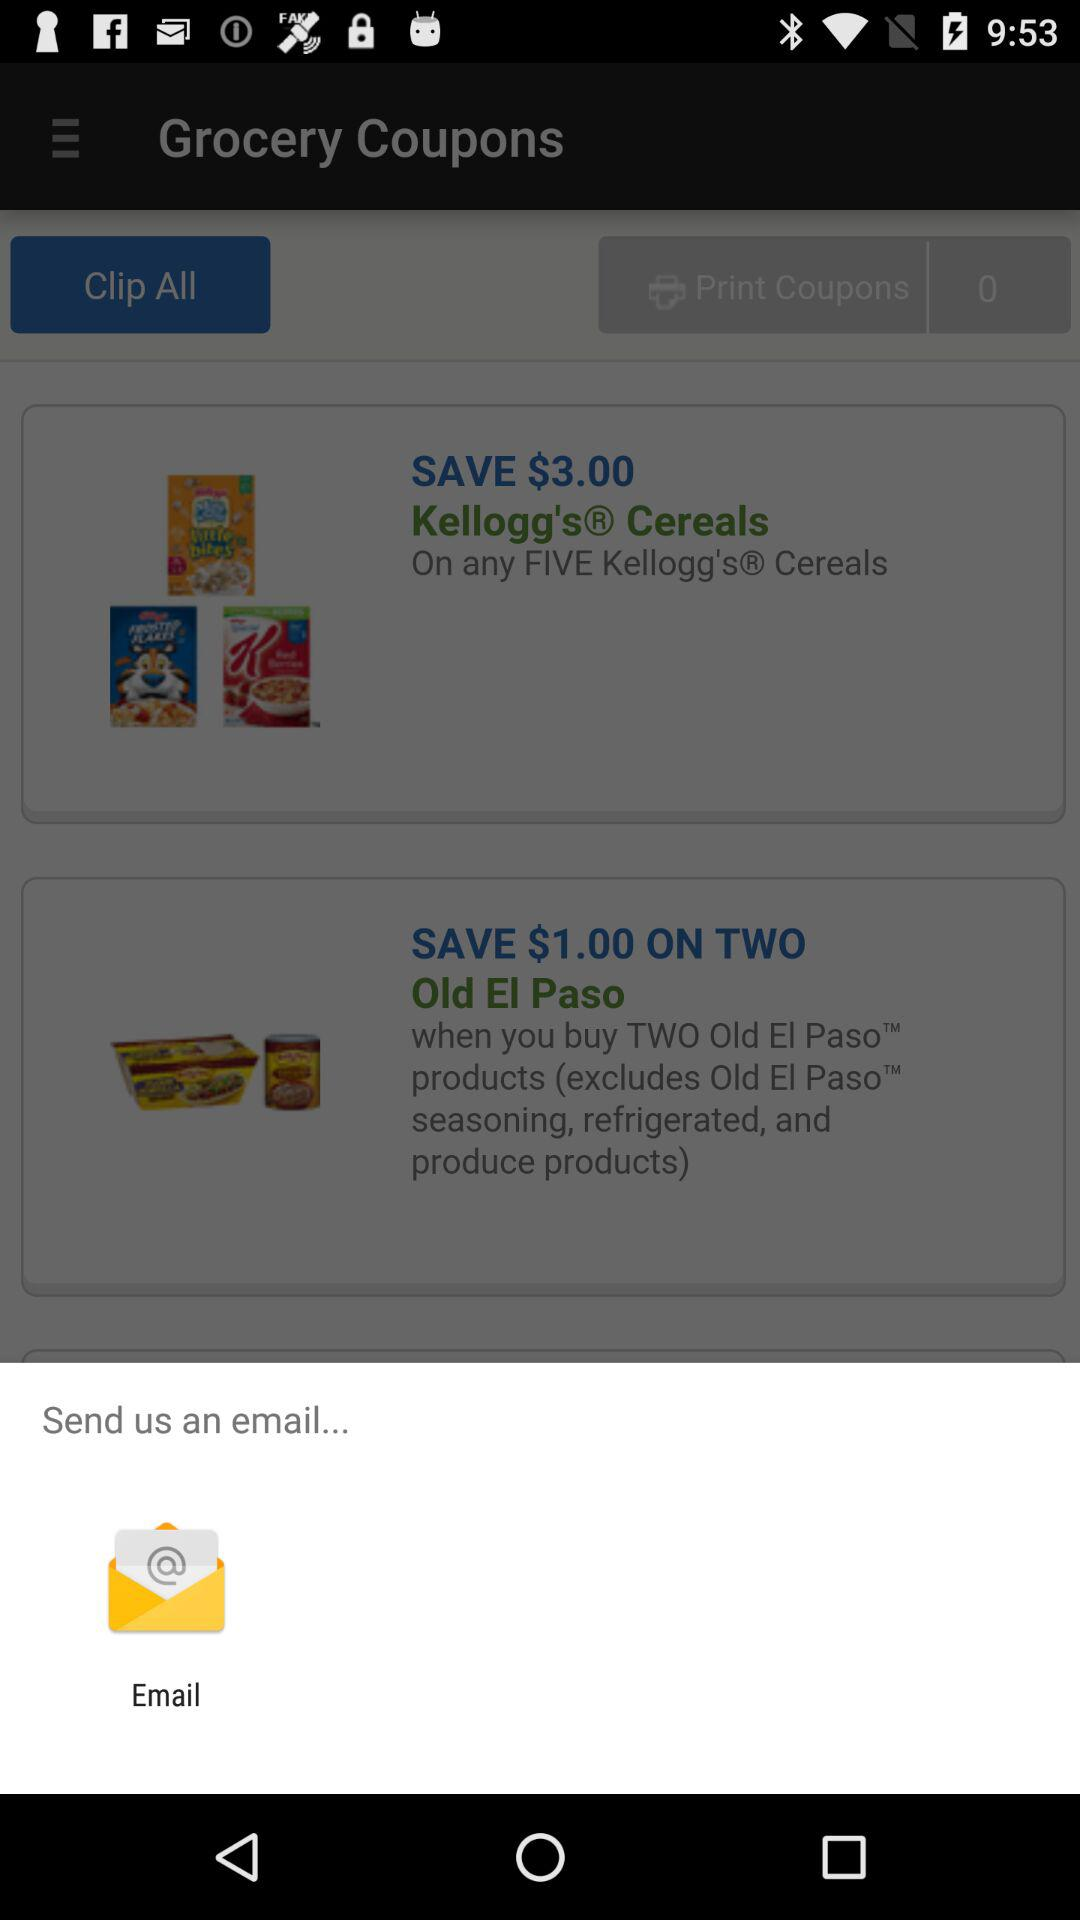How much can be saved on "Kellogg's Cereals"? You can save $3.00 on "Kellogg's Cereals". 